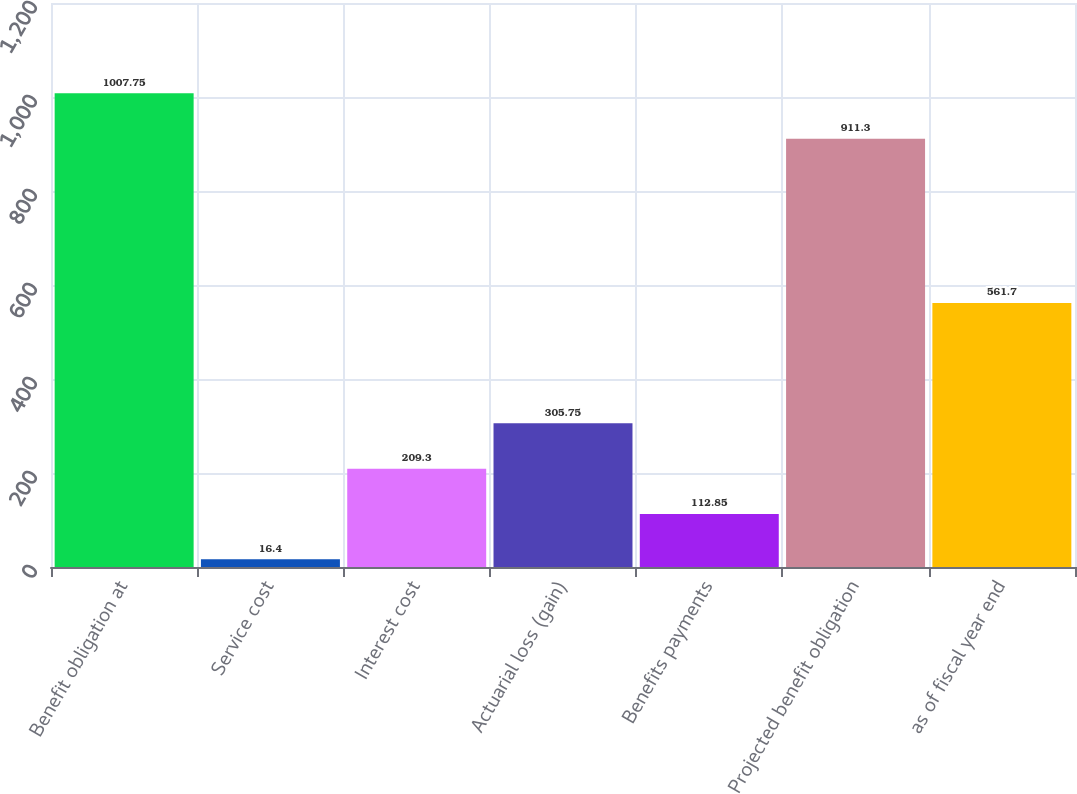<chart> <loc_0><loc_0><loc_500><loc_500><bar_chart><fcel>Benefit obligation at<fcel>Service cost<fcel>Interest cost<fcel>Actuarial loss (gain)<fcel>Benefits payments<fcel>Projected benefit obligation<fcel>as of fiscal year end<nl><fcel>1007.75<fcel>16.4<fcel>209.3<fcel>305.75<fcel>112.85<fcel>911.3<fcel>561.7<nl></chart> 